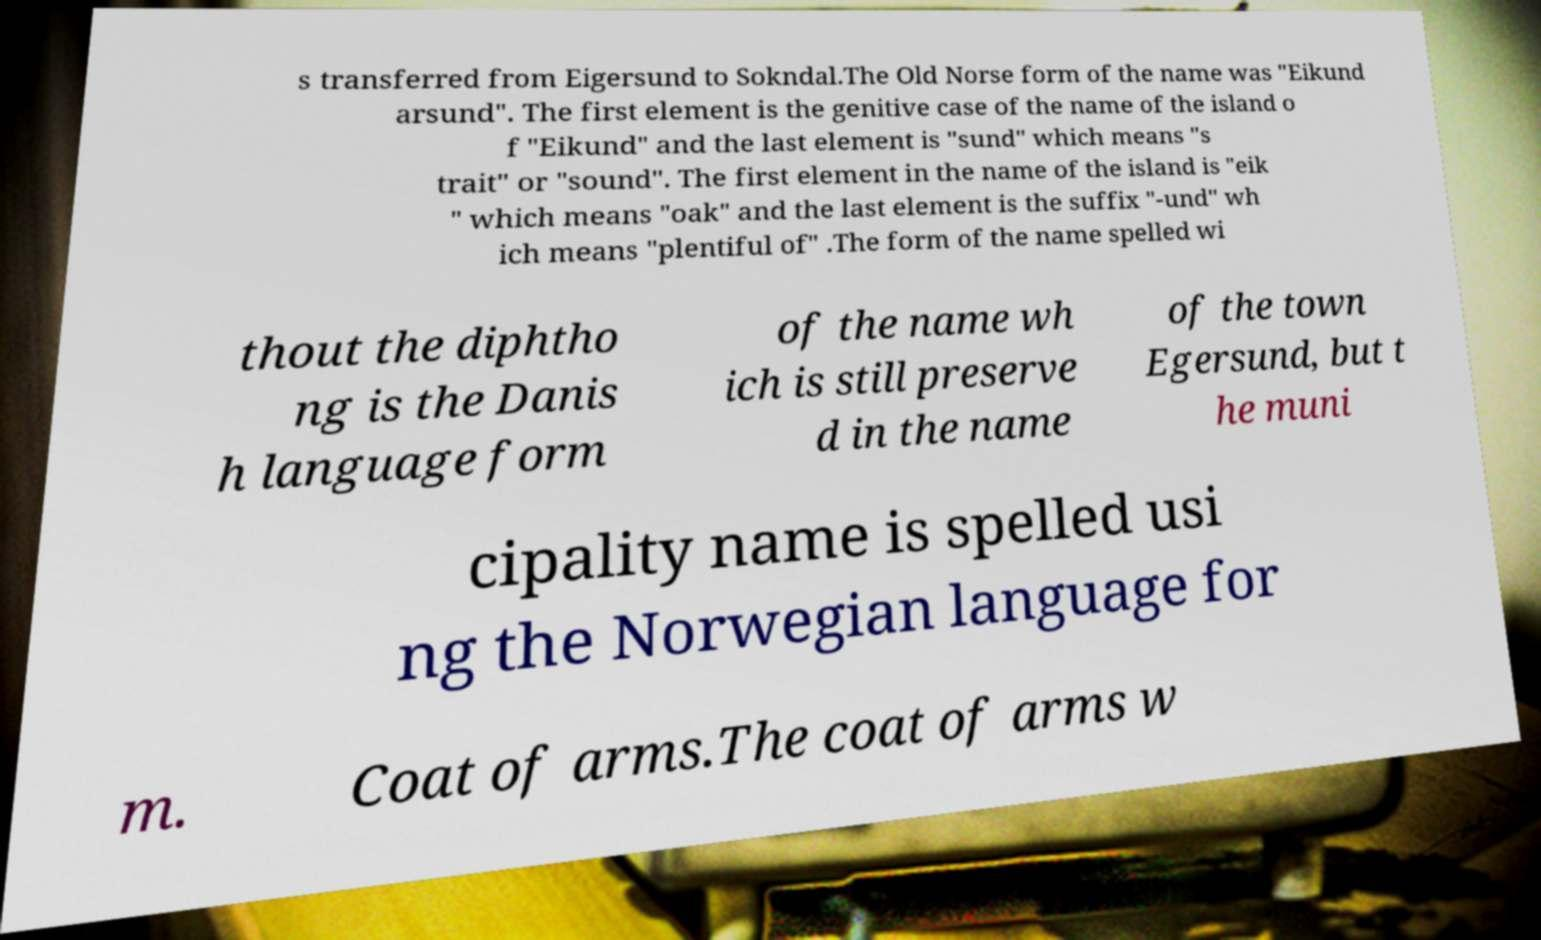Please read and relay the text visible in this image. What does it say? s transferred from Eigersund to Sokndal.The Old Norse form of the name was "Eikund arsund". The first element is the genitive case of the name of the island o f "Eikund" and the last element is "sund" which means "s trait" or "sound". The first element in the name of the island is "eik " which means "oak" and the last element is the suffix "-und" wh ich means "plentiful of" .The form of the name spelled wi thout the diphtho ng is the Danis h language form of the name wh ich is still preserve d in the name of the town Egersund, but t he muni cipality name is spelled usi ng the Norwegian language for m. Coat of arms.The coat of arms w 